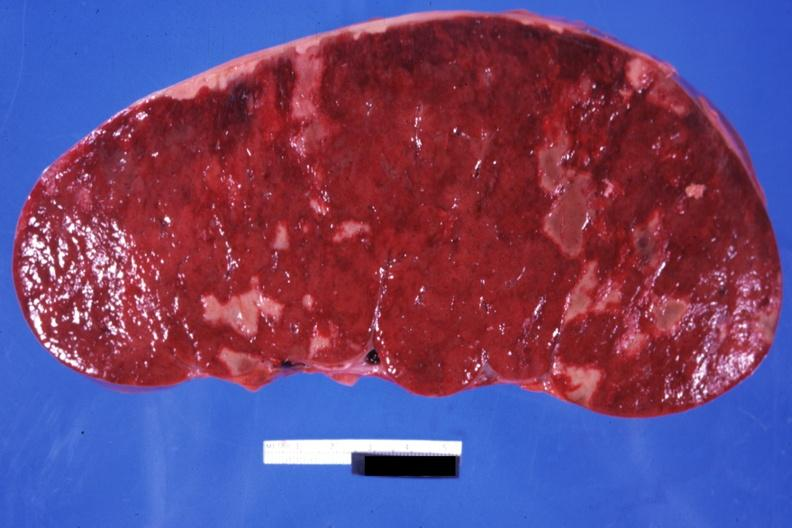what does this image show?
Answer the question using a single word or phrase. Very enlarged spleen with multiple infarcts infiltrative process is easily seen 